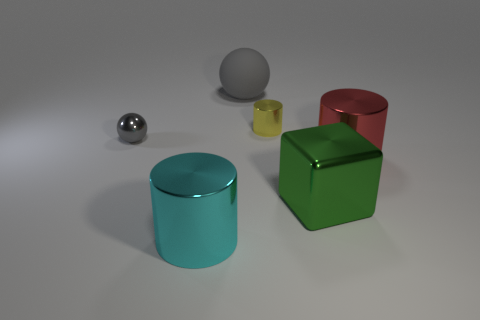What is the material of the ball behind the tiny thing that is left of the big cyan thing?
Keep it short and to the point. Rubber. Are there any other spheres that have the same material as the big sphere?
Offer a terse response. No. The metal thing that is behind the metallic object that is left of the metal cylinder left of the big gray sphere is what shape?
Your response must be concise. Cylinder. What is the yellow cylinder made of?
Your answer should be compact. Metal. What is the color of the small cylinder that is the same material as the cyan object?
Offer a terse response. Yellow. There is a big thing behind the small gray thing; are there any red cylinders that are behind it?
Your response must be concise. No. What number of other things are the same shape as the yellow thing?
Keep it short and to the point. 2. Is the shape of the big gray object that is behind the tiny yellow metal thing the same as the gray object that is left of the big rubber ball?
Keep it short and to the point. Yes. There is a small object to the right of the big object that is left of the rubber ball; what number of big blocks are to the left of it?
Provide a succinct answer. 0. What color is the tiny metal cylinder?
Give a very brief answer. Yellow. 